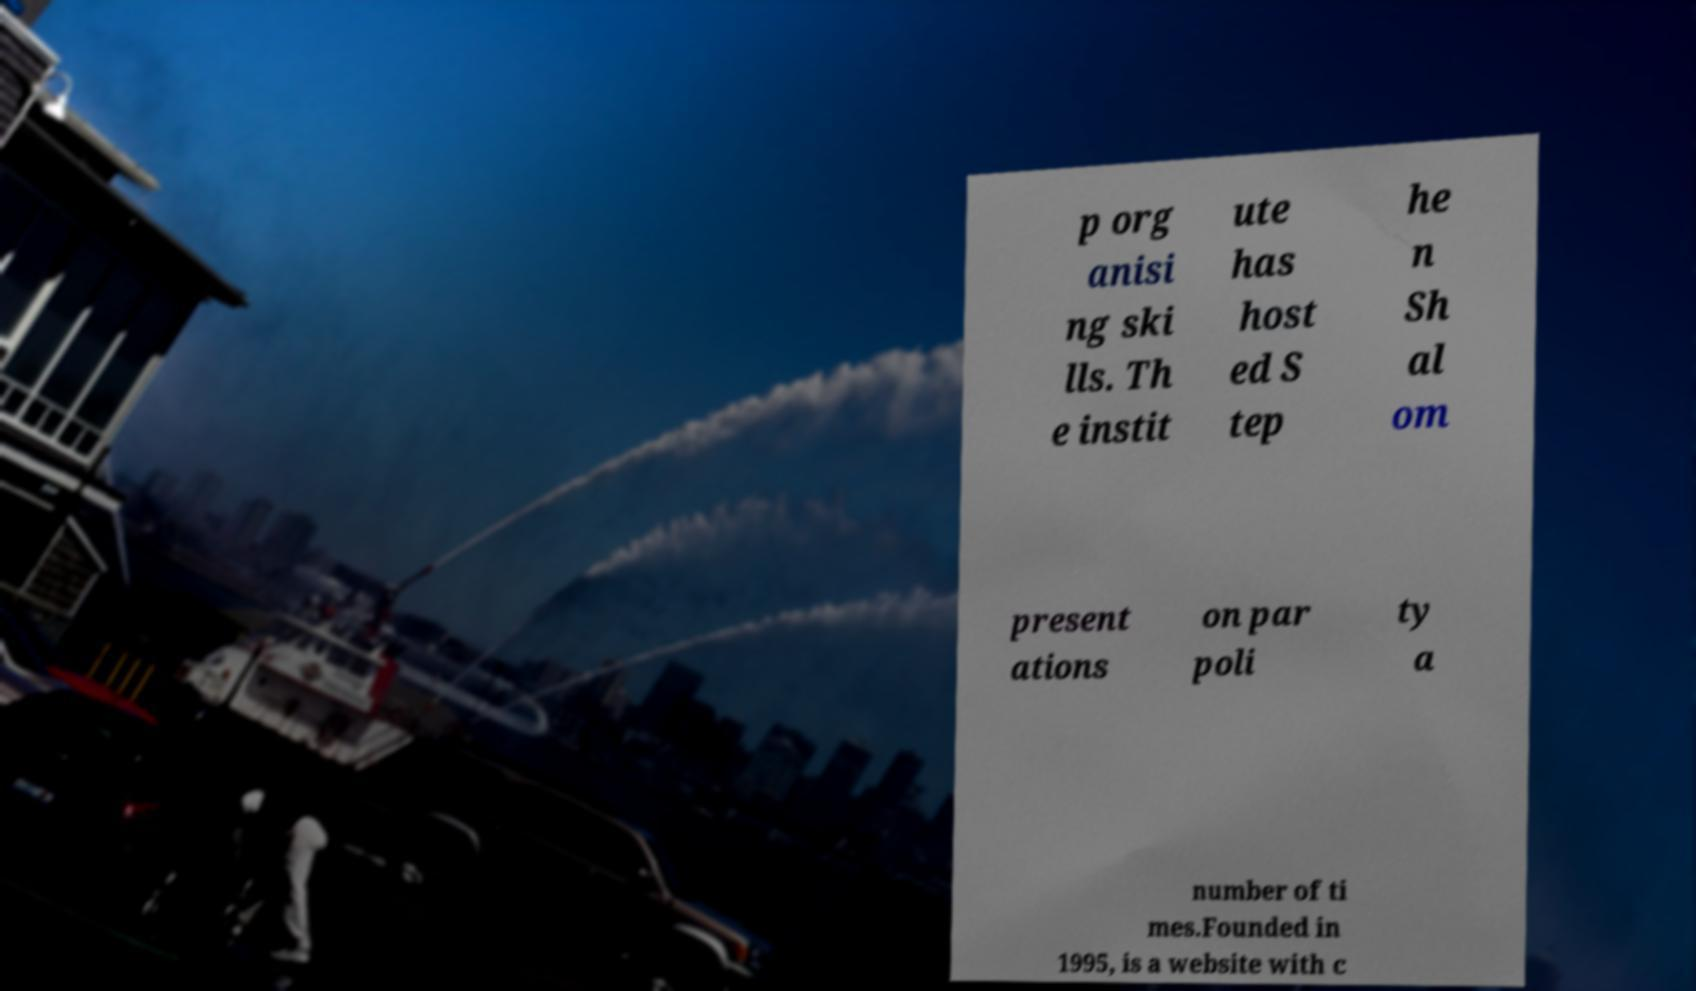For documentation purposes, I need the text within this image transcribed. Could you provide that? p org anisi ng ski lls. Th e instit ute has host ed S tep he n Sh al om present ations on par poli ty a number of ti mes.Founded in 1995, is a website with c 